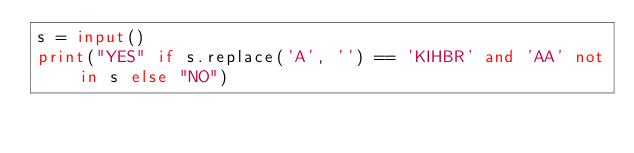<code> <loc_0><loc_0><loc_500><loc_500><_Python_>s = input()
print("YES" if s.replace('A', '') == 'KIHBR' and 'AA' not in s else "NO")</code> 